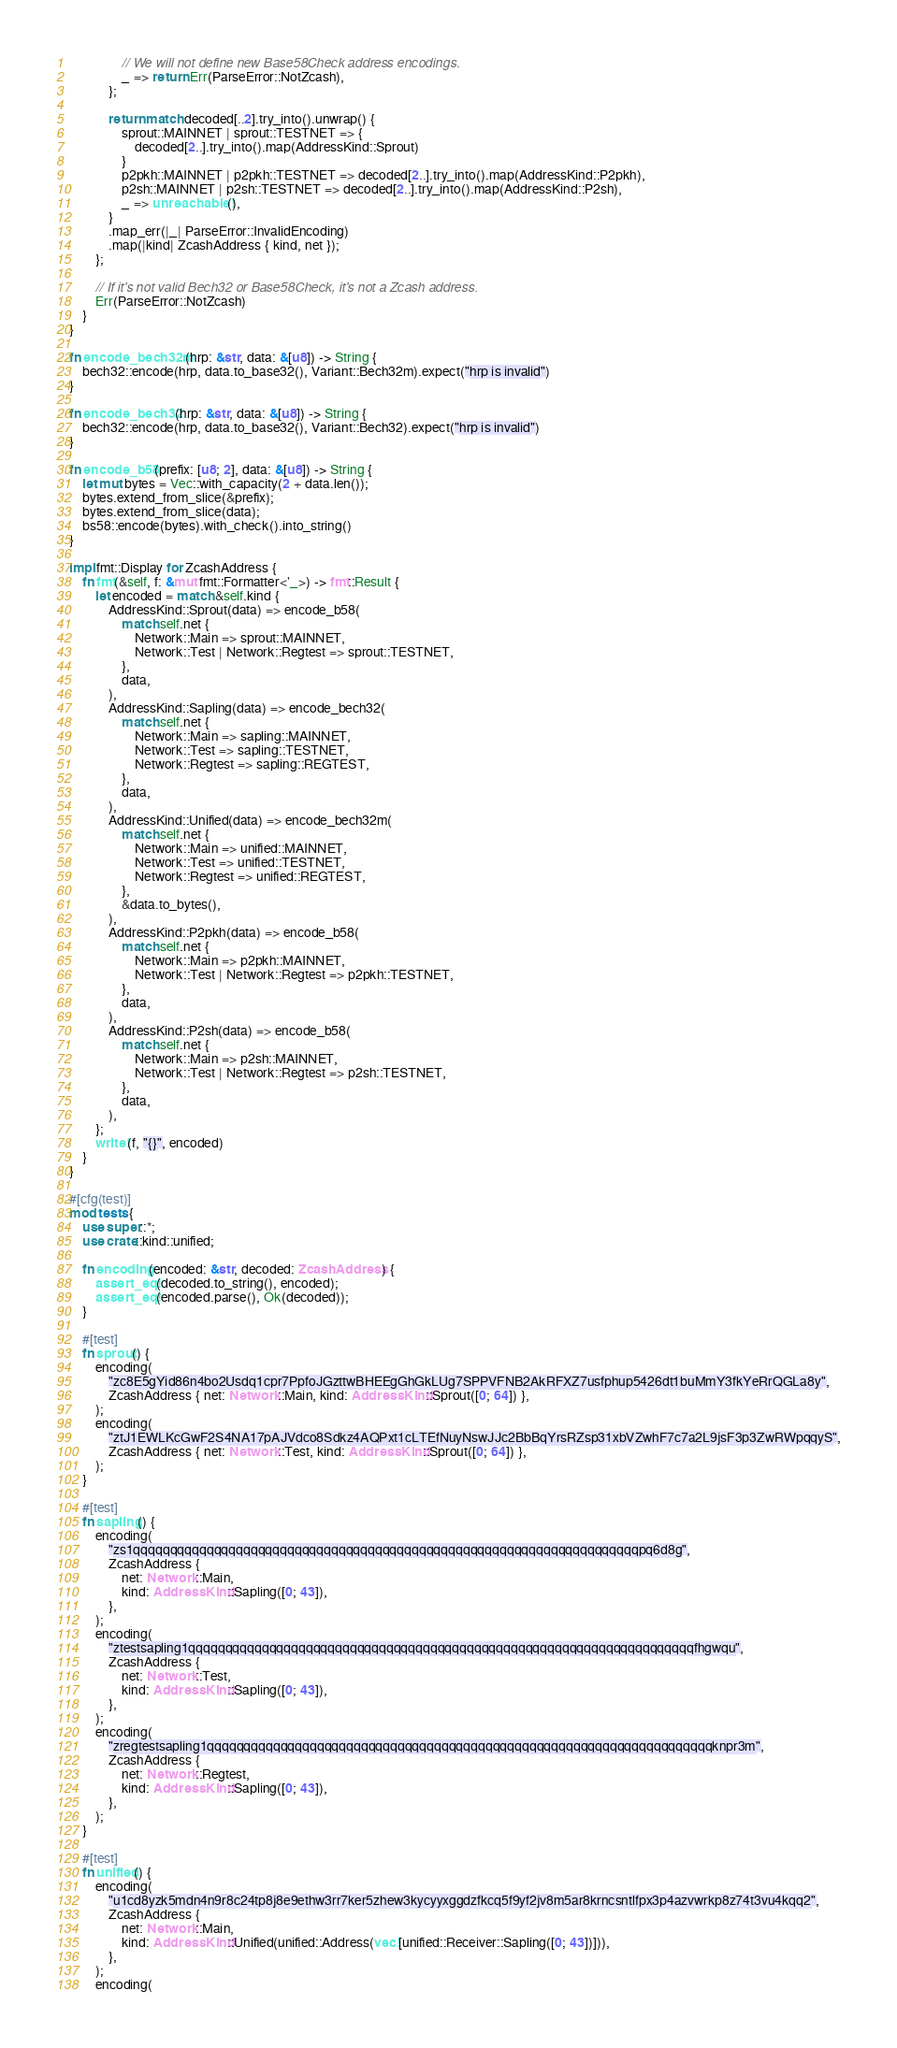<code> <loc_0><loc_0><loc_500><loc_500><_Rust_>                // We will not define new Base58Check address encodings.
                _ => return Err(ParseError::NotZcash),
            };

            return match decoded[..2].try_into().unwrap() {
                sprout::MAINNET | sprout::TESTNET => {
                    decoded[2..].try_into().map(AddressKind::Sprout)
                }
                p2pkh::MAINNET | p2pkh::TESTNET => decoded[2..].try_into().map(AddressKind::P2pkh),
                p2sh::MAINNET | p2sh::TESTNET => decoded[2..].try_into().map(AddressKind::P2sh),
                _ => unreachable!(),
            }
            .map_err(|_| ParseError::InvalidEncoding)
            .map(|kind| ZcashAddress { kind, net });
        };

        // If it's not valid Bech32 or Base58Check, it's not a Zcash address.
        Err(ParseError::NotZcash)
    }
}

fn encode_bech32m(hrp: &str, data: &[u8]) -> String {
    bech32::encode(hrp, data.to_base32(), Variant::Bech32m).expect("hrp is invalid")
}

fn encode_bech32(hrp: &str, data: &[u8]) -> String {
    bech32::encode(hrp, data.to_base32(), Variant::Bech32).expect("hrp is invalid")
}

fn encode_b58(prefix: [u8; 2], data: &[u8]) -> String {
    let mut bytes = Vec::with_capacity(2 + data.len());
    bytes.extend_from_slice(&prefix);
    bytes.extend_from_slice(data);
    bs58::encode(bytes).with_check().into_string()
}

impl fmt::Display for ZcashAddress {
    fn fmt(&self, f: &mut fmt::Formatter<'_>) -> fmt::Result {
        let encoded = match &self.kind {
            AddressKind::Sprout(data) => encode_b58(
                match self.net {
                    Network::Main => sprout::MAINNET,
                    Network::Test | Network::Regtest => sprout::TESTNET,
                },
                data,
            ),
            AddressKind::Sapling(data) => encode_bech32(
                match self.net {
                    Network::Main => sapling::MAINNET,
                    Network::Test => sapling::TESTNET,
                    Network::Regtest => sapling::REGTEST,
                },
                data,
            ),
            AddressKind::Unified(data) => encode_bech32m(
                match self.net {
                    Network::Main => unified::MAINNET,
                    Network::Test => unified::TESTNET,
                    Network::Regtest => unified::REGTEST,
                },
                &data.to_bytes(),
            ),
            AddressKind::P2pkh(data) => encode_b58(
                match self.net {
                    Network::Main => p2pkh::MAINNET,
                    Network::Test | Network::Regtest => p2pkh::TESTNET,
                },
                data,
            ),
            AddressKind::P2sh(data) => encode_b58(
                match self.net {
                    Network::Main => p2sh::MAINNET,
                    Network::Test | Network::Regtest => p2sh::TESTNET,
                },
                data,
            ),
        };
        write!(f, "{}", encoded)
    }
}

#[cfg(test)]
mod tests {
    use super::*;
    use crate::kind::unified;

    fn encoding(encoded: &str, decoded: ZcashAddress) {
        assert_eq!(decoded.to_string(), encoded);
        assert_eq!(encoded.parse(), Ok(decoded));
    }

    #[test]
    fn sprout() {
        encoding(
            "zc8E5gYid86n4bo2Usdq1cpr7PpfoJGzttwBHEEgGhGkLUg7SPPVFNB2AkRFXZ7usfphup5426dt1buMmY3fkYeRrQGLa8y",
            ZcashAddress { net: Network::Main, kind: AddressKind::Sprout([0; 64]) },
        );
        encoding(
            "ztJ1EWLKcGwF2S4NA17pAJVdco8Sdkz4AQPxt1cLTEfNuyNswJJc2BbBqYrsRZsp31xbVZwhF7c7a2L9jsF3p3ZwRWpqqyS",
            ZcashAddress { net: Network::Test, kind: AddressKind::Sprout([0; 64]) },
        );
    }

    #[test]
    fn sapling() {
        encoding(
            "zs1qqqqqqqqqqqqqqqqqqqqqqqqqqqqqqqqqqqqqqqqqqqqqqqqqqqqqqqqqqqqqqqqqqqqqpq6d8g",
            ZcashAddress {
                net: Network::Main,
                kind: AddressKind::Sapling([0; 43]),
            },
        );
        encoding(
            "ztestsapling1qqqqqqqqqqqqqqqqqqqqqqqqqqqqqqqqqqqqqqqqqqqqqqqqqqqqqqqqqqqqqqqqqqqqqfhgwqu",
            ZcashAddress {
                net: Network::Test,
                kind: AddressKind::Sapling([0; 43]),
            },
        );
        encoding(
            "zregtestsapling1qqqqqqqqqqqqqqqqqqqqqqqqqqqqqqqqqqqqqqqqqqqqqqqqqqqqqqqqqqqqqqqqqqqqqknpr3m",
            ZcashAddress {
                net: Network::Regtest,
                kind: AddressKind::Sapling([0; 43]),
            },
        );
    }

    #[test]
    fn unified() {
        encoding(
            "u1cd8yzk5mdn4n9r8c24tp8j8e9ethw3rr7ker5zhew3kycyyxggdzfkcq5f9yf2jv8m5ar8krncsntlfpx3p4azvwrkp8z74t3vu4kqq2",
            ZcashAddress {
                net: Network::Main,
                kind: AddressKind::Unified(unified::Address(vec![unified::Receiver::Sapling([0; 43])])),
            },
        );
        encoding(</code> 